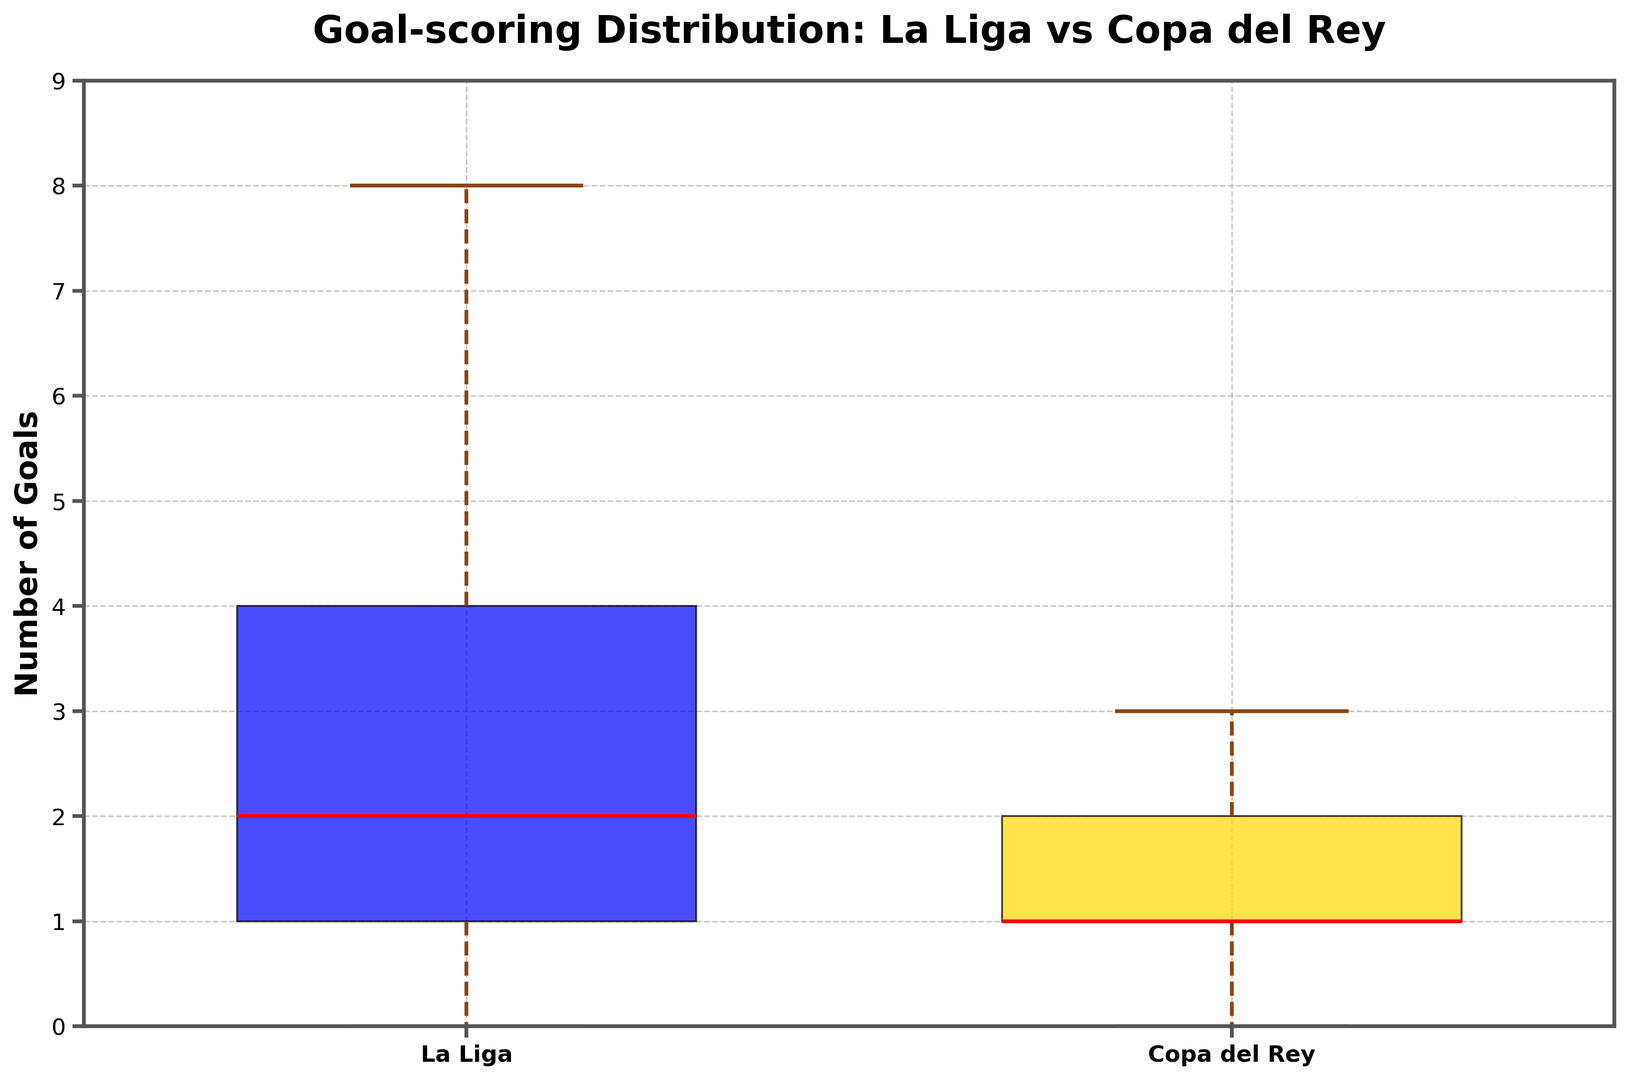What are the median goal values for Cádiz CF strikers in both La Liga and Copa del Rey matches? To determine the median goal values from the box plot, observe the red lines within the boxes (which represent the median). Identify these values for both La Liga and Copa del Rey matches.
Answer: La Liga: 2, Copa del Rey: 1 Which competition shows a higher interquartile range (IQR) for goals? The IQR is the range between the first quartile (Q1) and the third quartile (Q3) in the box plot. Compare the length of the boxes (middle 50%) in La Liga and Copa del Rey plots. The competition with the longer box indicates a higher IQR.
Answer: La Liga Do Cádiz CF strikers score more goals on average in La Liga or Copa del Rey? Compare the positions of the boxes and whiskers within the plots. If the positions are higher for La Liga, this suggests a higher average. Otherwise, it's higher for Copa del Rey.
Answer: La Liga What's the maximum number of goals scored by a striker in Copa del Rey? The highest point in the Copa del Rey box plot whisker represents the maximum number of goals scored. Identify this value from the plot.
Answer: 3 Which competition has a greater variability in goal-scoring among Cádiz CF strikers? The variability can be inferred from the length of the whiskers and the presence of outliers. Compare the overall spread of the data represented by the whiskers and outliers in both competitions.
Answer: La Liga What is the minimum number of goals scored by a Cádiz CF striker in La Liga? The lowest point in the La Liga box plot whisker represents the minimum number of goals scored. Identify this value from the plot.
Answer: 0 Are there any outliers present in either competition's goal distribution? Outliers in a box plot are represented by points beyond the whiskers. Observe both the La Liga and Copa del Rey plots to check for any such points.
Answer: No Which competition shows a closer median to its maximum goal value? Compare the distance between the median (red line) and the maximum point (top edge of the whisker) in both La Liga and Copa del Rey plots. The closer distance indicates the competition with a closer median to its maximum goal value.
Answer: Copa del Rey Which competition has a wider range of goal scores? The range is the difference between maximum and minimum values. Compare the range (difference between the top and bottom whiskers) in La Liga and Copa del Rey plots.
Answer: La Liga Are the goal distributions skewed for La Liga or Copa del Rey? Skewness in a box plot can be inferred if the median line is closer to one side of the box. Determine the skewness by observing if the red median line is closer to the bottom or top within the boxes for both competitions.
Answer: Both distributions are somewhat right-skewed 